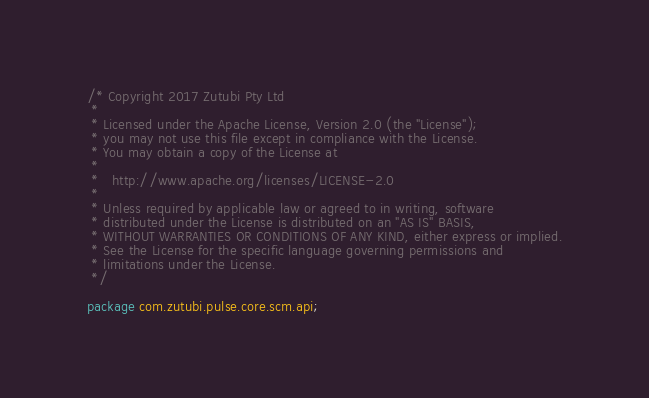Convert code to text. <code><loc_0><loc_0><loc_500><loc_500><_Java_>/* Copyright 2017 Zutubi Pty Ltd
 *
 * Licensed under the Apache License, Version 2.0 (the "License");
 * you may not use this file except in compliance with the License.
 * You may obtain a copy of the License at
 *
 *   http://www.apache.org/licenses/LICENSE-2.0
 *
 * Unless required by applicable law or agreed to in writing, software
 * distributed under the License is distributed on an "AS IS" BASIS,
 * WITHOUT WARRANTIES OR CONDITIONS OF ANY KIND, either express or implied.
 * See the License for the specific language governing permissions and
 * limitations under the License.
 */

package com.zutubi.pulse.core.scm.api;
</code> 